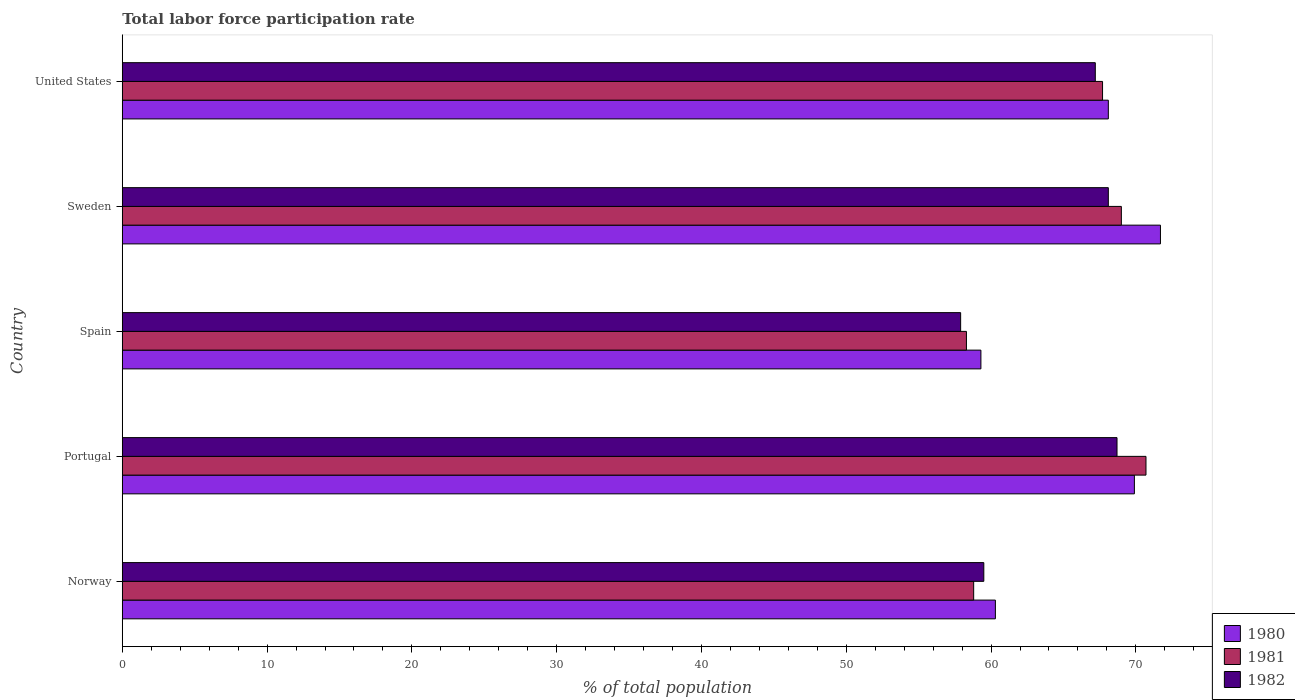How many groups of bars are there?
Provide a succinct answer. 5. How many bars are there on the 4th tick from the bottom?
Ensure brevity in your answer.  3. What is the label of the 5th group of bars from the top?
Your response must be concise. Norway. What is the total labor force participation rate in 1980 in Portugal?
Make the answer very short. 69.9. Across all countries, what is the maximum total labor force participation rate in 1980?
Your answer should be compact. 71.7. Across all countries, what is the minimum total labor force participation rate in 1982?
Give a very brief answer. 57.9. What is the total total labor force participation rate in 1980 in the graph?
Ensure brevity in your answer.  329.3. What is the difference between the total labor force participation rate in 1982 in Spain and that in Sweden?
Provide a succinct answer. -10.2. What is the difference between the total labor force participation rate in 1980 in Norway and the total labor force participation rate in 1981 in Sweden?
Your answer should be very brief. -8.7. What is the average total labor force participation rate in 1982 per country?
Provide a short and direct response. 64.28. What is the difference between the total labor force participation rate in 1982 and total labor force participation rate in 1980 in Portugal?
Make the answer very short. -1.2. In how many countries, is the total labor force participation rate in 1982 greater than 32 %?
Your response must be concise. 5. What is the ratio of the total labor force participation rate in 1981 in Norway to that in United States?
Ensure brevity in your answer.  0.87. What is the difference between the highest and the second highest total labor force participation rate in 1982?
Provide a succinct answer. 0.6. What is the difference between the highest and the lowest total labor force participation rate in 1980?
Provide a short and direct response. 12.4. Is the sum of the total labor force participation rate in 1982 in Spain and United States greater than the maximum total labor force participation rate in 1981 across all countries?
Your answer should be compact. Yes. What does the 1st bar from the top in United States represents?
Your answer should be compact. 1982. What does the 3rd bar from the bottom in Spain represents?
Give a very brief answer. 1982. How many bars are there?
Your response must be concise. 15. Are all the bars in the graph horizontal?
Provide a succinct answer. Yes. What is the difference between two consecutive major ticks on the X-axis?
Your answer should be very brief. 10. Are the values on the major ticks of X-axis written in scientific E-notation?
Ensure brevity in your answer.  No. Does the graph contain any zero values?
Ensure brevity in your answer.  No. Where does the legend appear in the graph?
Your answer should be very brief. Bottom right. How many legend labels are there?
Offer a terse response. 3. How are the legend labels stacked?
Offer a very short reply. Vertical. What is the title of the graph?
Your answer should be compact. Total labor force participation rate. Does "2000" appear as one of the legend labels in the graph?
Offer a terse response. No. What is the label or title of the X-axis?
Offer a very short reply. % of total population. What is the % of total population of 1980 in Norway?
Your response must be concise. 60.3. What is the % of total population in 1981 in Norway?
Give a very brief answer. 58.8. What is the % of total population of 1982 in Norway?
Your answer should be compact. 59.5. What is the % of total population in 1980 in Portugal?
Offer a very short reply. 69.9. What is the % of total population in 1981 in Portugal?
Ensure brevity in your answer.  70.7. What is the % of total population of 1982 in Portugal?
Ensure brevity in your answer.  68.7. What is the % of total population of 1980 in Spain?
Make the answer very short. 59.3. What is the % of total population of 1981 in Spain?
Provide a short and direct response. 58.3. What is the % of total population of 1982 in Spain?
Provide a short and direct response. 57.9. What is the % of total population of 1980 in Sweden?
Make the answer very short. 71.7. What is the % of total population of 1981 in Sweden?
Offer a terse response. 69. What is the % of total population of 1982 in Sweden?
Offer a very short reply. 68.1. What is the % of total population in 1980 in United States?
Keep it short and to the point. 68.1. What is the % of total population in 1981 in United States?
Provide a short and direct response. 67.7. What is the % of total population in 1982 in United States?
Offer a terse response. 67.2. Across all countries, what is the maximum % of total population in 1980?
Your answer should be compact. 71.7. Across all countries, what is the maximum % of total population in 1981?
Offer a very short reply. 70.7. Across all countries, what is the maximum % of total population of 1982?
Your response must be concise. 68.7. Across all countries, what is the minimum % of total population of 1980?
Your answer should be very brief. 59.3. Across all countries, what is the minimum % of total population in 1981?
Give a very brief answer. 58.3. Across all countries, what is the minimum % of total population of 1982?
Ensure brevity in your answer.  57.9. What is the total % of total population of 1980 in the graph?
Make the answer very short. 329.3. What is the total % of total population in 1981 in the graph?
Your answer should be very brief. 324.5. What is the total % of total population of 1982 in the graph?
Your answer should be very brief. 321.4. What is the difference between the % of total population of 1980 in Norway and that in Portugal?
Your answer should be compact. -9.6. What is the difference between the % of total population in 1981 in Norway and that in Portugal?
Your response must be concise. -11.9. What is the difference between the % of total population in 1982 in Norway and that in Portugal?
Ensure brevity in your answer.  -9.2. What is the difference between the % of total population in 1980 in Norway and that in Spain?
Offer a terse response. 1. What is the difference between the % of total population in 1981 in Norway and that in Spain?
Offer a very short reply. 0.5. What is the difference between the % of total population in 1980 in Norway and that in Sweden?
Offer a very short reply. -11.4. What is the difference between the % of total population of 1982 in Norway and that in Sweden?
Your answer should be compact. -8.6. What is the difference between the % of total population of 1981 in Norway and that in United States?
Ensure brevity in your answer.  -8.9. What is the difference between the % of total population in 1982 in Norway and that in United States?
Make the answer very short. -7.7. What is the difference between the % of total population of 1981 in Portugal and that in Sweden?
Give a very brief answer. 1.7. What is the difference between the % of total population in 1982 in Portugal and that in United States?
Provide a succinct answer. 1.5. What is the difference between the % of total population of 1981 in Spain and that in United States?
Keep it short and to the point. -9.4. What is the difference between the % of total population in 1982 in Spain and that in United States?
Keep it short and to the point. -9.3. What is the difference between the % of total population in 1980 in Sweden and that in United States?
Offer a very short reply. 3.6. What is the difference between the % of total population of 1981 in Sweden and that in United States?
Your answer should be very brief. 1.3. What is the difference between the % of total population in 1980 in Norway and the % of total population in 1981 in Portugal?
Offer a very short reply. -10.4. What is the difference between the % of total population in 1980 in Norway and the % of total population in 1982 in Portugal?
Your answer should be compact. -8.4. What is the difference between the % of total population of 1980 in Norway and the % of total population of 1982 in Spain?
Keep it short and to the point. 2.4. What is the difference between the % of total population in 1980 in Norway and the % of total population in 1982 in Sweden?
Make the answer very short. -7.8. What is the difference between the % of total population in 1980 in Norway and the % of total population in 1981 in United States?
Ensure brevity in your answer.  -7.4. What is the difference between the % of total population of 1980 in Norway and the % of total population of 1982 in United States?
Your response must be concise. -6.9. What is the difference between the % of total population of 1980 in Portugal and the % of total population of 1981 in Spain?
Give a very brief answer. 11.6. What is the difference between the % of total population in 1980 in Portugal and the % of total population in 1982 in Spain?
Your response must be concise. 12. What is the difference between the % of total population in 1980 in Portugal and the % of total population in 1981 in Sweden?
Keep it short and to the point. 0.9. What is the difference between the % of total population in 1980 in Portugal and the % of total population in 1982 in Sweden?
Offer a terse response. 1.8. What is the difference between the % of total population of 1981 in Portugal and the % of total population of 1982 in Sweden?
Your response must be concise. 2.6. What is the difference between the % of total population of 1980 in Portugal and the % of total population of 1981 in United States?
Offer a terse response. 2.2. What is the difference between the % of total population of 1980 in Spain and the % of total population of 1982 in Sweden?
Keep it short and to the point. -8.8. What is the difference between the % of total population in 1980 in Spain and the % of total population in 1981 in United States?
Ensure brevity in your answer.  -8.4. What is the difference between the % of total population in 1980 in Sweden and the % of total population in 1981 in United States?
Provide a succinct answer. 4. What is the difference between the % of total population in 1980 in Sweden and the % of total population in 1982 in United States?
Provide a succinct answer. 4.5. What is the average % of total population in 1980 per country?
Provide a succinct answer. 65.86. What is the average % of total population in 1981 per country?
Keep it short and to the point. 64.9. What is the average % of total population in 1982 per country?
Provide a short and direct response. 64.28. What is the difference between the % of total population of 1980 and % of total population of 1981 in Norway?
Offer a very short reply. 1.5. What is the difference between the % of total population of 1980 and % of total population of 1981 in Portugal?
Provide a succinct answer. -0.8. What is the difference between the % of total population of 1980 and % of total population of 1981 in Spain?
Keep it short and to the point. 1. What is the difference between the % of total population in 1981 and % of total population in 1982 in Spain?
Provide a succinct answer. 0.4. What is the difference between the % of total population in 1981 and % of total population in 1982 in Sweden?
Provide a succinct answer. 0.9. What is the difference between the % of total population of 1980 and % of total population of 1981 in United States?
Make the answer very short. 0.4. What is the ratio of the % of total population in 1980 in Norway to that in Portugal?
Make the answer very short. 0.86. What is the ratio of the % of total population of 1981 in Norway to that in Portugal?
Provide a short and direct response. 0.83. What is the ratio of the % of total population of 1982 in Norway to that in Portugal?
Keep it short and to the point. 0.87. What is the ratio of the % of total population of 1980 in Norway to that in Spain?
Provide a short and direct response. 1.02. What is the ratio of the % of total population of 1981 in Norway to that in Spain?
Ensure brevity in your answer.  1.01. What is the ratio of the % of total population in 1982 in Norway to that in Spain?
Your answer should be very brief. 1.03. What is the ratio of the % of total population in 1980 in Norway to that in Sweden?
Offer a terse response. 0.84. What is the ratio of the % of total population of 1981 in Norway to that in Sweden?
Offer a terse response. 0.85. What is the ratio of the % of total population of 1982 in Norway to that in Sweden?
Your response must be concise. 0.87. What is the ratio of the % of total population of 1980 in Norway to that in United States?
Provide a short and direct response. 0.89. What is the ratio of the % of total population in 1981 in Norway to that in United States?
Ensure brevity in your answer.  0.87. What is the ratio of the % of total population of 1982 in Norway to that in United States?
Make the answer very short. 0.89. What is the ratio of the % of total population in 1980 in Portugal to that in Spain?
Your response must be concise. 1.18. What is the ratio of the % of total population in 1981 in Portugal to that in Spain?
Ensure brevity in your answer.  1.21. What is the ratio of the % of total population in 1982 in Portugal to that in Spain?
Make the answer very short. 1.19. What is the ratio of the % of total population in 1980 in Portugal to that in Sweden?
Provide a short and direct response. 0.97. What is the ratio of the % of total population in 1981 in Portugal to that in Sweden?
Offer a terse response. 1.02. What is the ratio of the % of total population of 1982 in Portugal to that in Sweden?
Keep it short and to the point. 1.01. What is the ratio of the % of total population in 1980 in Portugal to that in United States?
Offer a terse response. 1.03. What is the ratio of the % of total population of 1981 in Portugal to that in United States?
Make the answer very short. 1.04. What is the ratio of the % of total population of 1982 in Portugal to that in United States?
Ensure brevity in your answer.  1.02. What is the ratio of the % of total population in 1980 in Spain to that in Sweden?
Ensure brevity in your answer.  0.83. What is the ratio of the % of total population of 1981 in Spain to that in Sweden?
Keep it short and to the point. 0.84. What is the ratio of the % of total population in 1982 in Spain to that in Sweden?
Give a very brief answer. 0.85. What is the ratio of the % of total population in 1980 in Spain to that in United States?
Your answer should be compact. 0.87. What is the ratio of the % of total population of 1981 in Spain to that in United States?
Give a very brief answer. 0.86. What is the ratio of the % of total population in 1982 in Spain to that in United States?
Your response must be concise. 0.86. What is the ratio of the % of total population in 1980 in Sweden to that in United States?
Your response must be concise. 1.05. What is the ratio of the % of total population in 1981 in Sweden to that in United States?
Offer a very short reply. 1.02. What is the ratio of the % of total population of 1982 in Sweden to that in United States?
Offer a terse response. 1.01. What is the difference between the highest and the second highest % of total population in 1981?
Give a very brief answer. 1.7. What is the difference between the highest and the second highest % of total population in 1982?
Give a very brief answer. 0.6. 